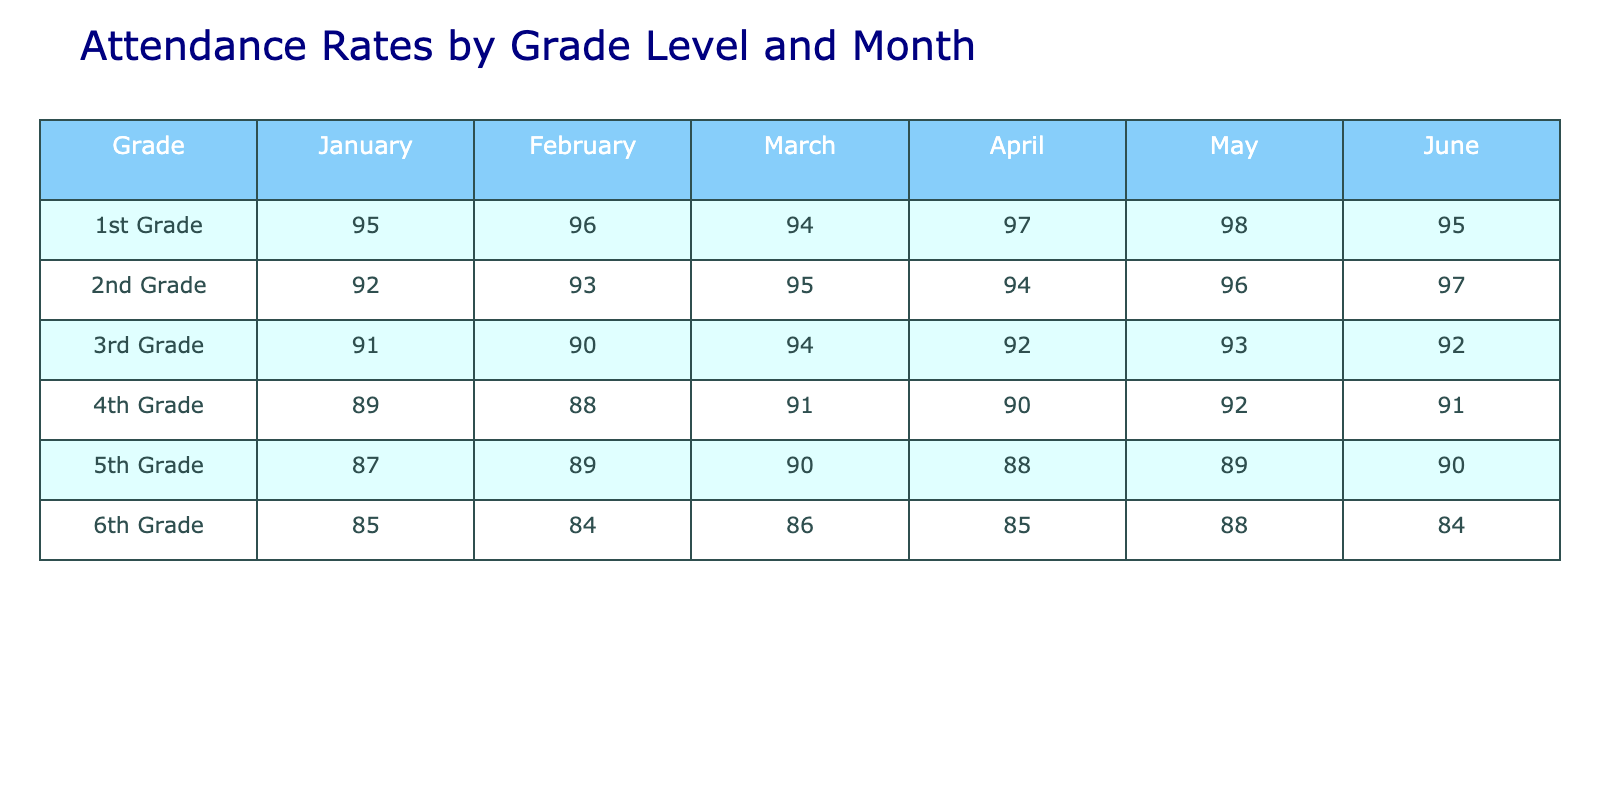What is the attendance rate for 1st Grade in May? The table shows that the attendance rate for 1st Grade in May is 98.
Answer: 98 Which grade had the highest attendance rate in April? By comparing the attendance rates in April for each grade, 1st Grade has the highest rate of 97.
Answer: 1st Grade What is the average attendance rate for 2nd Grade across all months? To find the average, add the attendance rates for 2nd Grade: (92 + 93 + 95 + 94 + 96 + 97) = 567. There are 6 months, so the average is 567/6 = 94.5.
Answer: 94.5 Did 6th Grade have an attendance rate of 90 or above in any month? Checking each month for 6th Grade, the rates are 85, 84, 86, 85, 88, and 84. None of these values are 90 or above.
Answer: No What is the difference between the attendance rates of 1st Grade and 4th Grade in February? For February, 1st Grade has an attendance of 96 and 4th Grade has 88. The difference is 96 - 88 = 8.
Answer: 8 Which grade experienced the lowest attendance rate in March? The table shows the attendance rates in March: 94, 95, 94, 91, 90, and 86. The lowest rate is for 6th Grade, which is 86.
Answer: 6th Grade What is the overall trend in attendance rates from January to June for 3rd Grade? Observing the rates: 91, 90, 94, 92, 93, and 92, we see minor fluctuations, but the highest is in March and May, with a slight drop in April, indicating stability with no clear increasing or decreasing trend.
Answer: No clear trend Which month did 5th Grade have the lowest attendance rate? Looking at the attendance rates for 5th Grade: 87, 89, 90, 88, 89, and 90, the lowest attendance rate was in January at 87.
Answer: January 